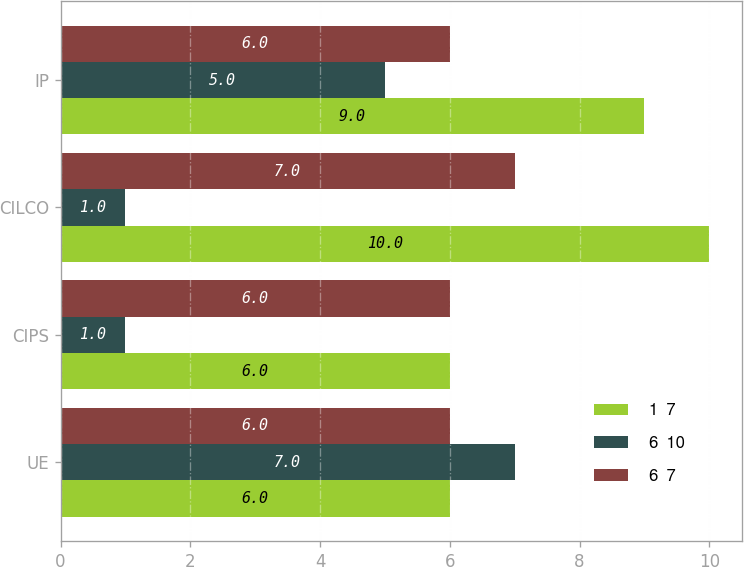Convert chart. <chart><loc_0><loc_0><loc_500><loc_500><stacked_bar_chart><ecel><fcel>UE<fcel>CIPS<fcel>CILCO<fcel>IP<nl><fcel>1  7<fcel>6<fcel>6<fcel>10<fcel>9<nl><fcel>6  10<fcel>7<fcel>1<fcel>1<fcel>5<nl><fcel>6  7<fcel>6<fcel>6<fcel>7<fcel>6<nl></chart> 